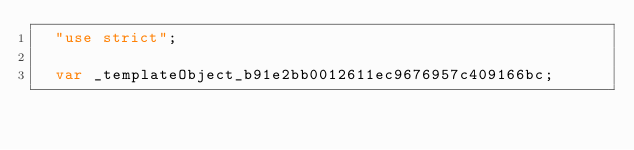Convert code to text. <code><loc_0><loc_0><loc_500><loc_500><_JavaScript_>  "use strict";

  var _templateObject_b91e2bb0012611ec9676957c409166bc;
</code> 